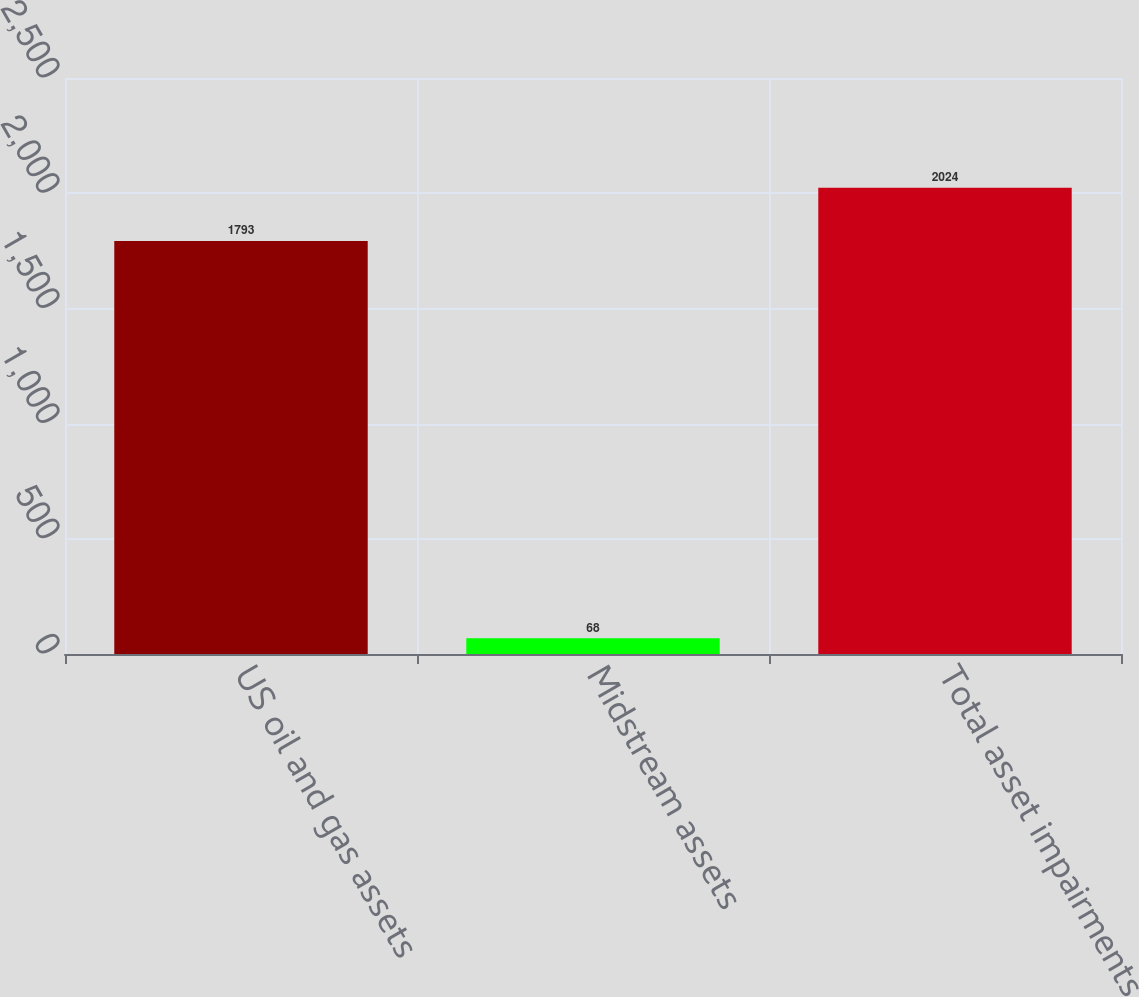Convert chart to OTSL. <chart><loc_0><loc_0><loc_500><loc_500><bar_chart><fcel>US oil and gas assets<fcel>Midstream assets<fcel>Total asset impairments<nl><fcel>1793<fcel>68<fcel>2024<nl></chart> 